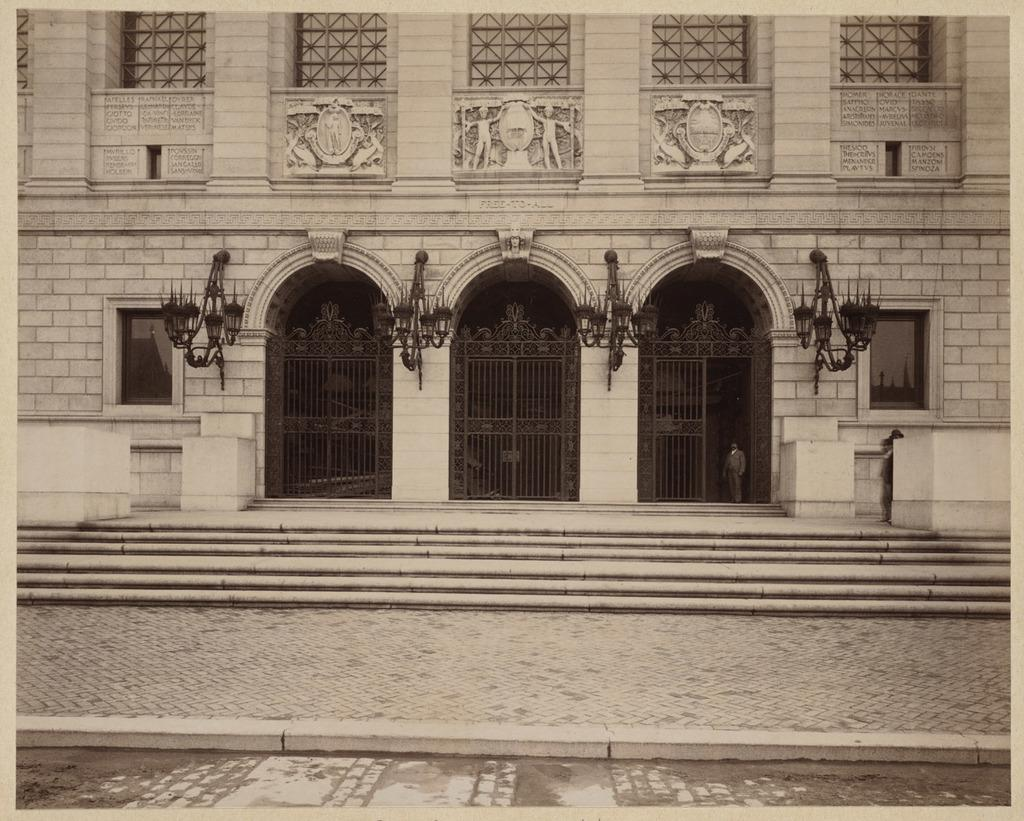What type of path is visible in the image? There is a footpath in the image. Are there any architectural features present in the image? Yes, there are steps, gates, and a building visible in the image. What can be seen in the building? There are lights, windows, and objects visible in the building. Can you describe the person standing in the image? There is a person standing in the image, but no specific details about their appearance or clothing are provided. What is the person's opinion on learning in the image? There is no information provided about the person's opinion on learning in the image. Can you hear the person whistling in the image? There is no mention of whistling or any sound in the image, so it cannot be determined if the person is whistling. 